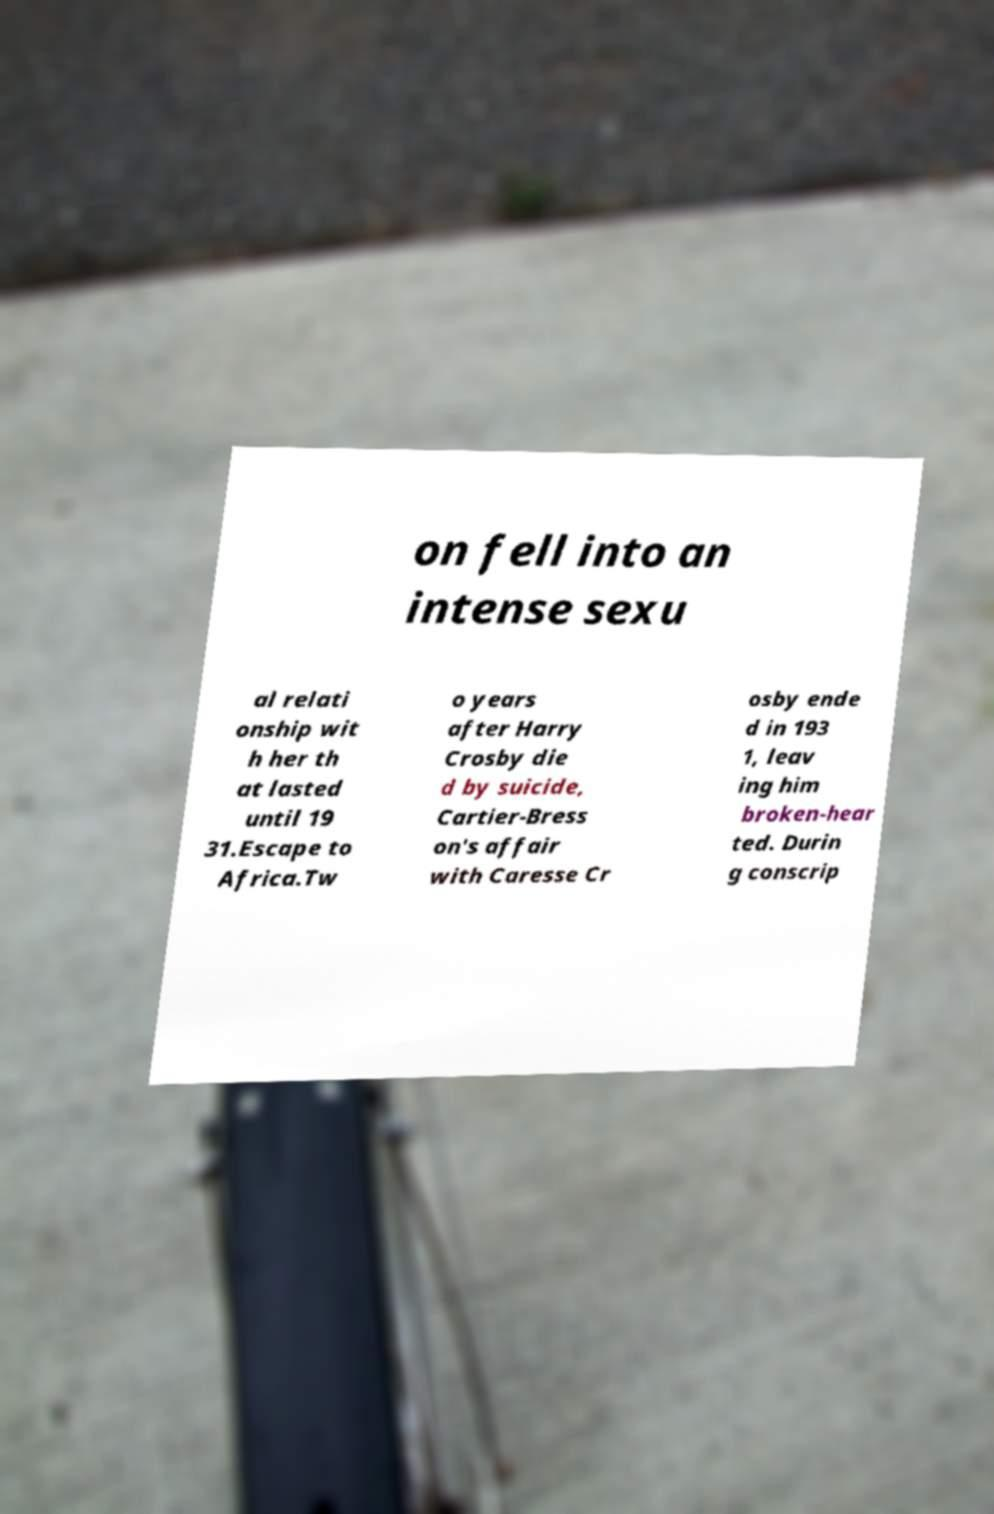Please read and relay the text visible in this image. What does it say? on fell into an intense sexu al relati onship wit h her th at lasted until 19 31.Escape to Africa.Tw o years after Harry Crosby die d by suicide, Cartier-Bress on's affair with Caresse Cr osby ende d in 193 1, leav ing him broken-hear ted. Durin g conscrip 